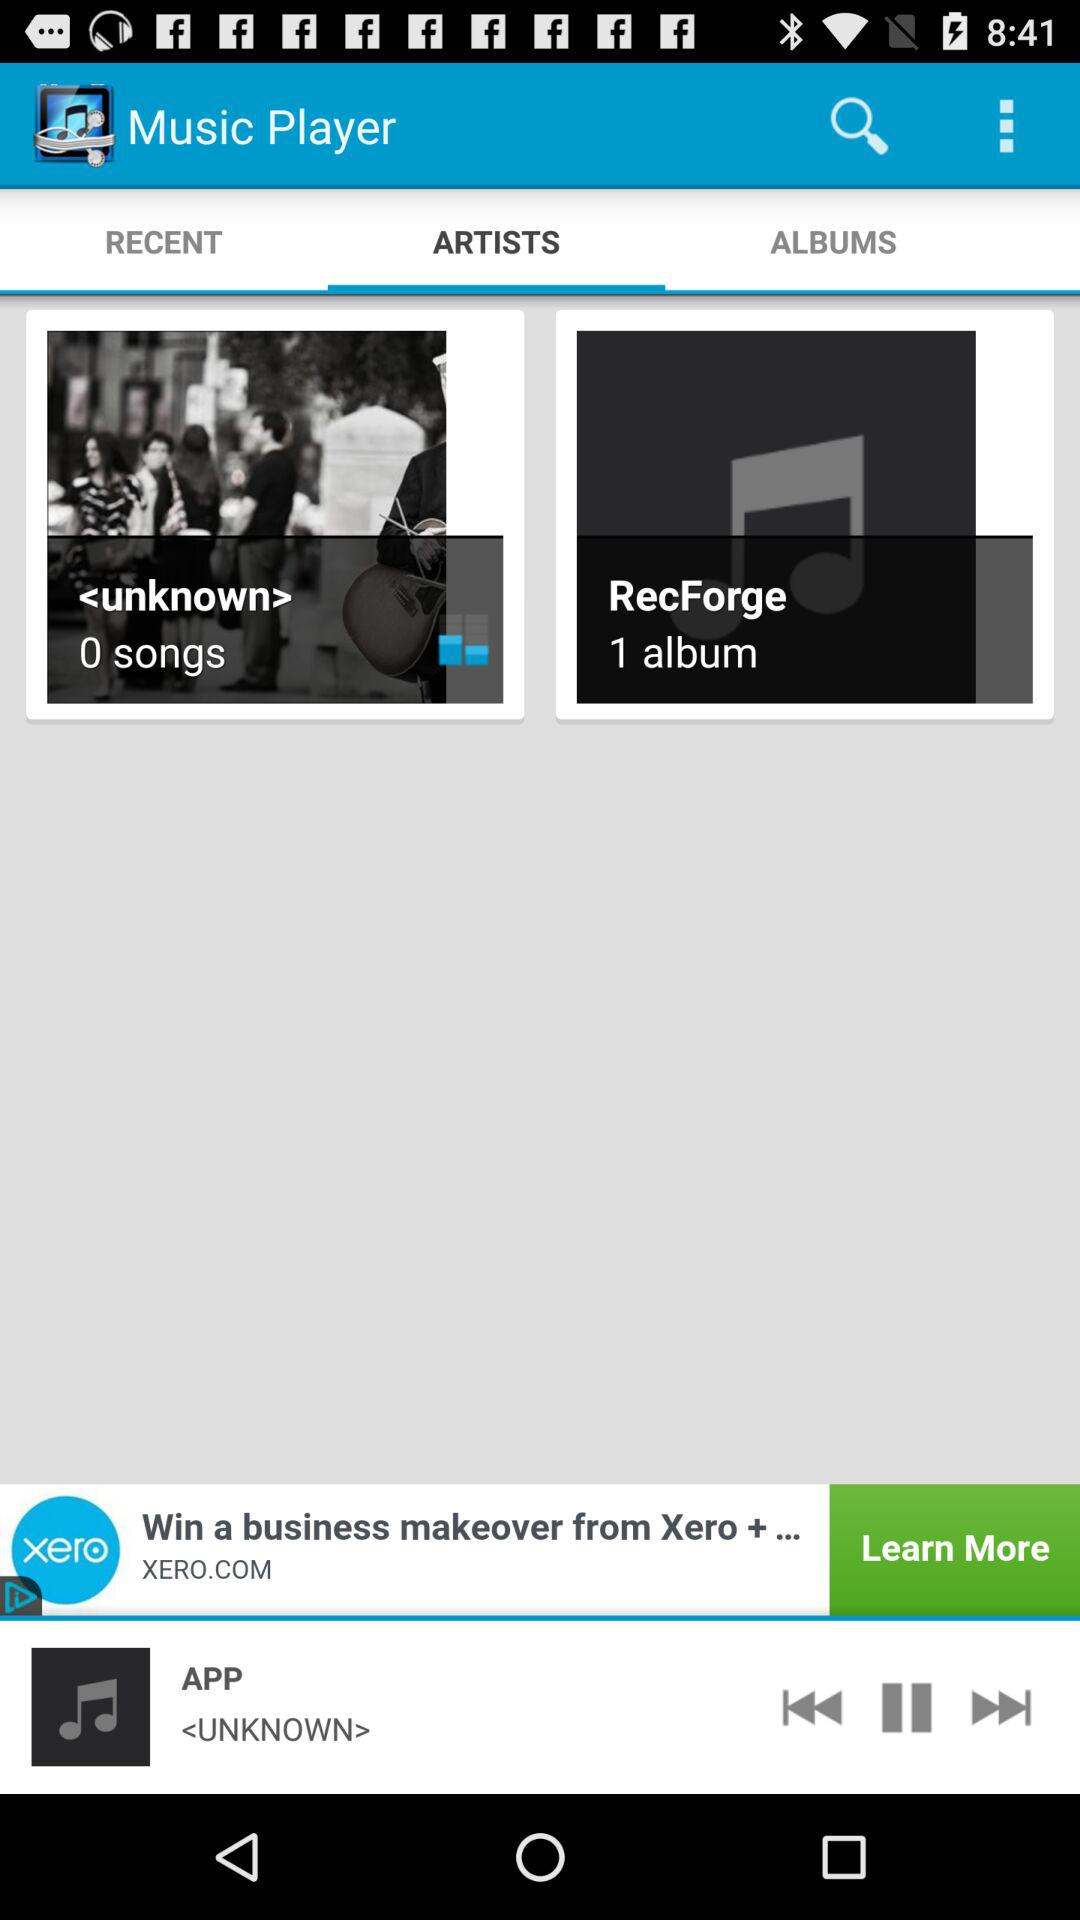What is the name of the application? The application name is "Music Player". 